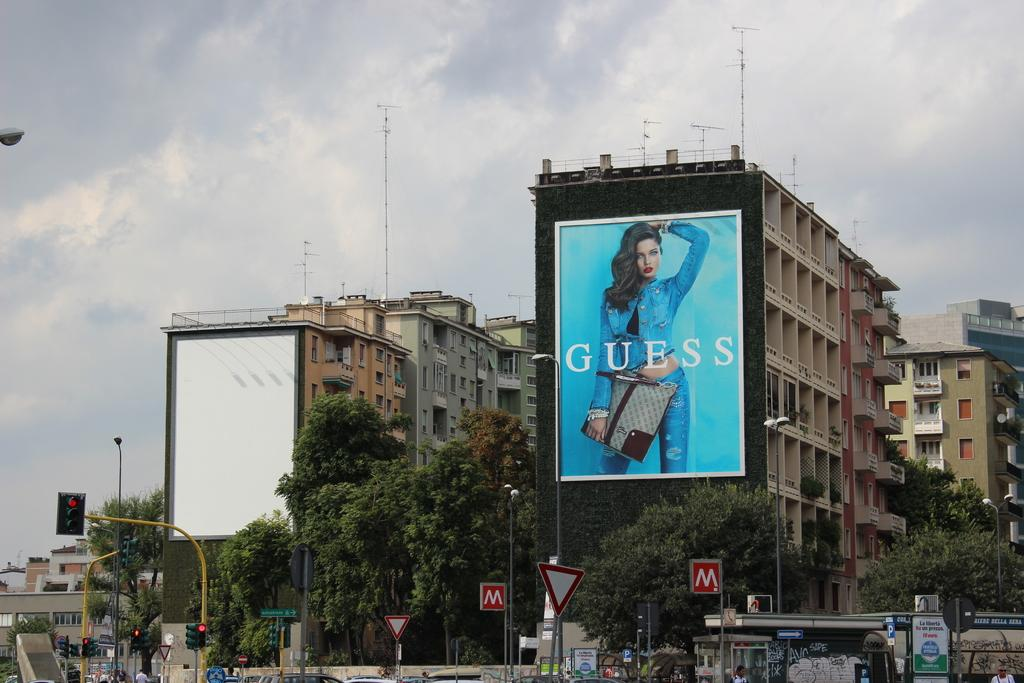<image>
Create a compact narrative representing the image presented. A huge advertisement from Guess with a young woman and blue background. 